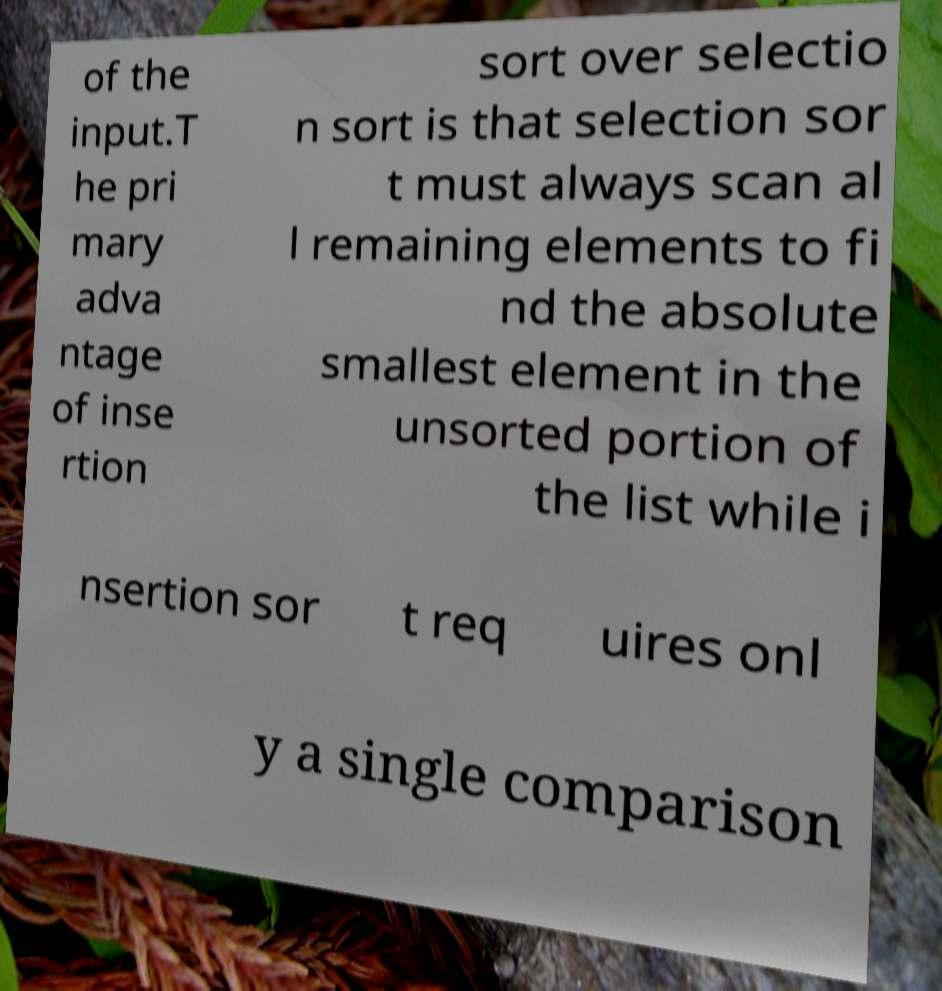Please read and relay the text visible in this image. What does it say? of the input.T he pri mary adva ntage of inse rtion sort over selectio n sort is that selection sor t must always scan al l remaining elements to fi nd the absolute smallest element in the unsorted portion of the list while i nsertion sor t req uires onl y a single comparison 